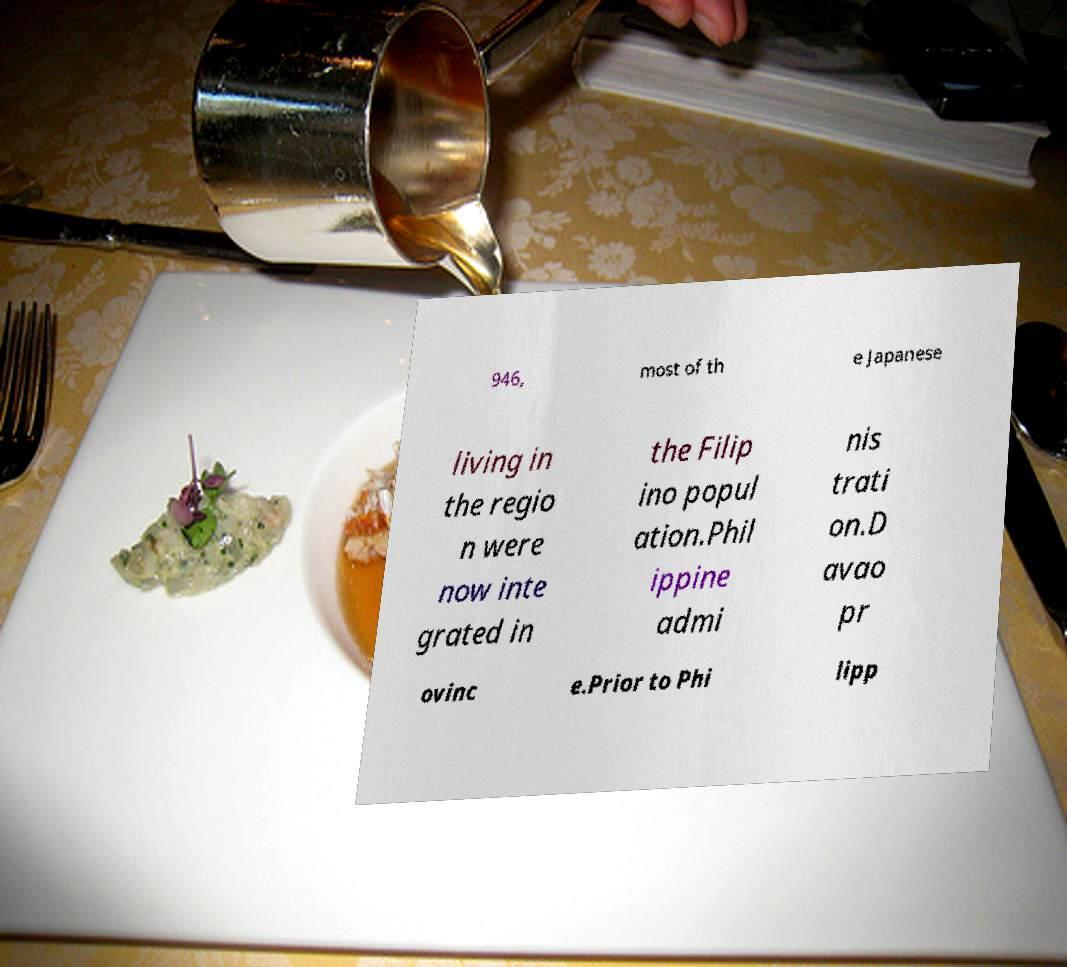What messages or text are displayed in this image? I need them in a readable, typed format. 946, most of th e Japanese living in the regio n were now inte grated in the Filip ino popul ation.Phil ippine admi nis trati on.D avao pr ovinc e.Prior to Phi lipp 